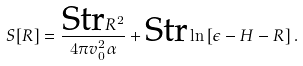Convert formula to latex. <formula><loc_0><loc_0><loc_500><loc_500>S [ R ] = \frac { \text {Str} R ^ { 2 } } { 4 \pi v _ { 0 } ^ { 2 } \alpha } + \text {Str} \ln \left [ \epsilon - H - R \right ] .</formula> 